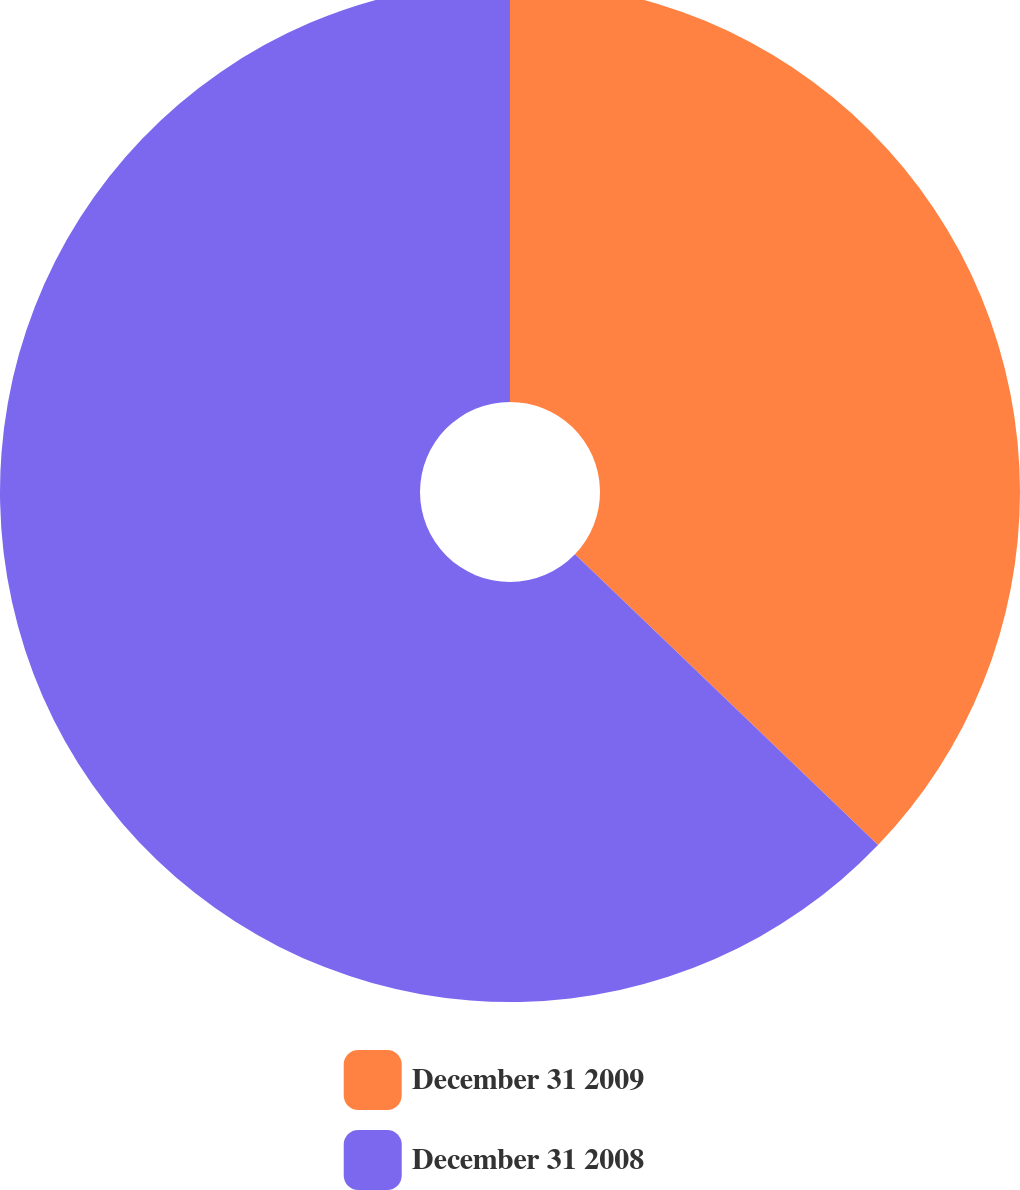<chart> <loc_0><loc_0><loc_500><loc_500><pie_chart><fcel>December 31 2009<fcel>December 31 2008<nl><fcel>37.17%<fcel>62.83%<nl></chart> 